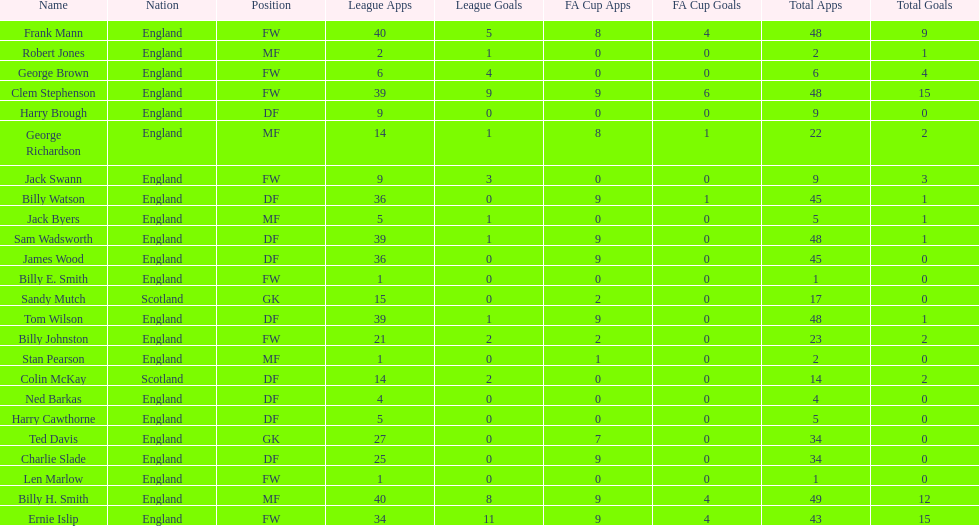Average number of goals scored by players from scotland 1. 